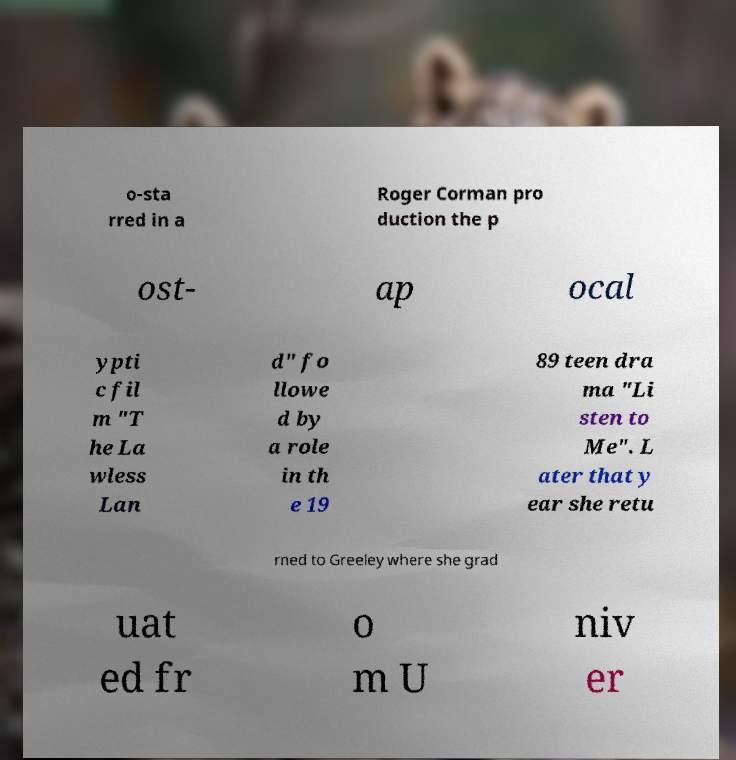Please read and relay the text visible in this image. What does it say? o-sta rred in a Roger Corman pro duction the p ost- ap ocal ypti c fil m "T he La wless Lan d" fo llowe d by a role in th e 19 89 teen dra ma "Li sten to Me". L ater that y ear she retu rned to Greeley where she grad uat ed fr o m U niv er 